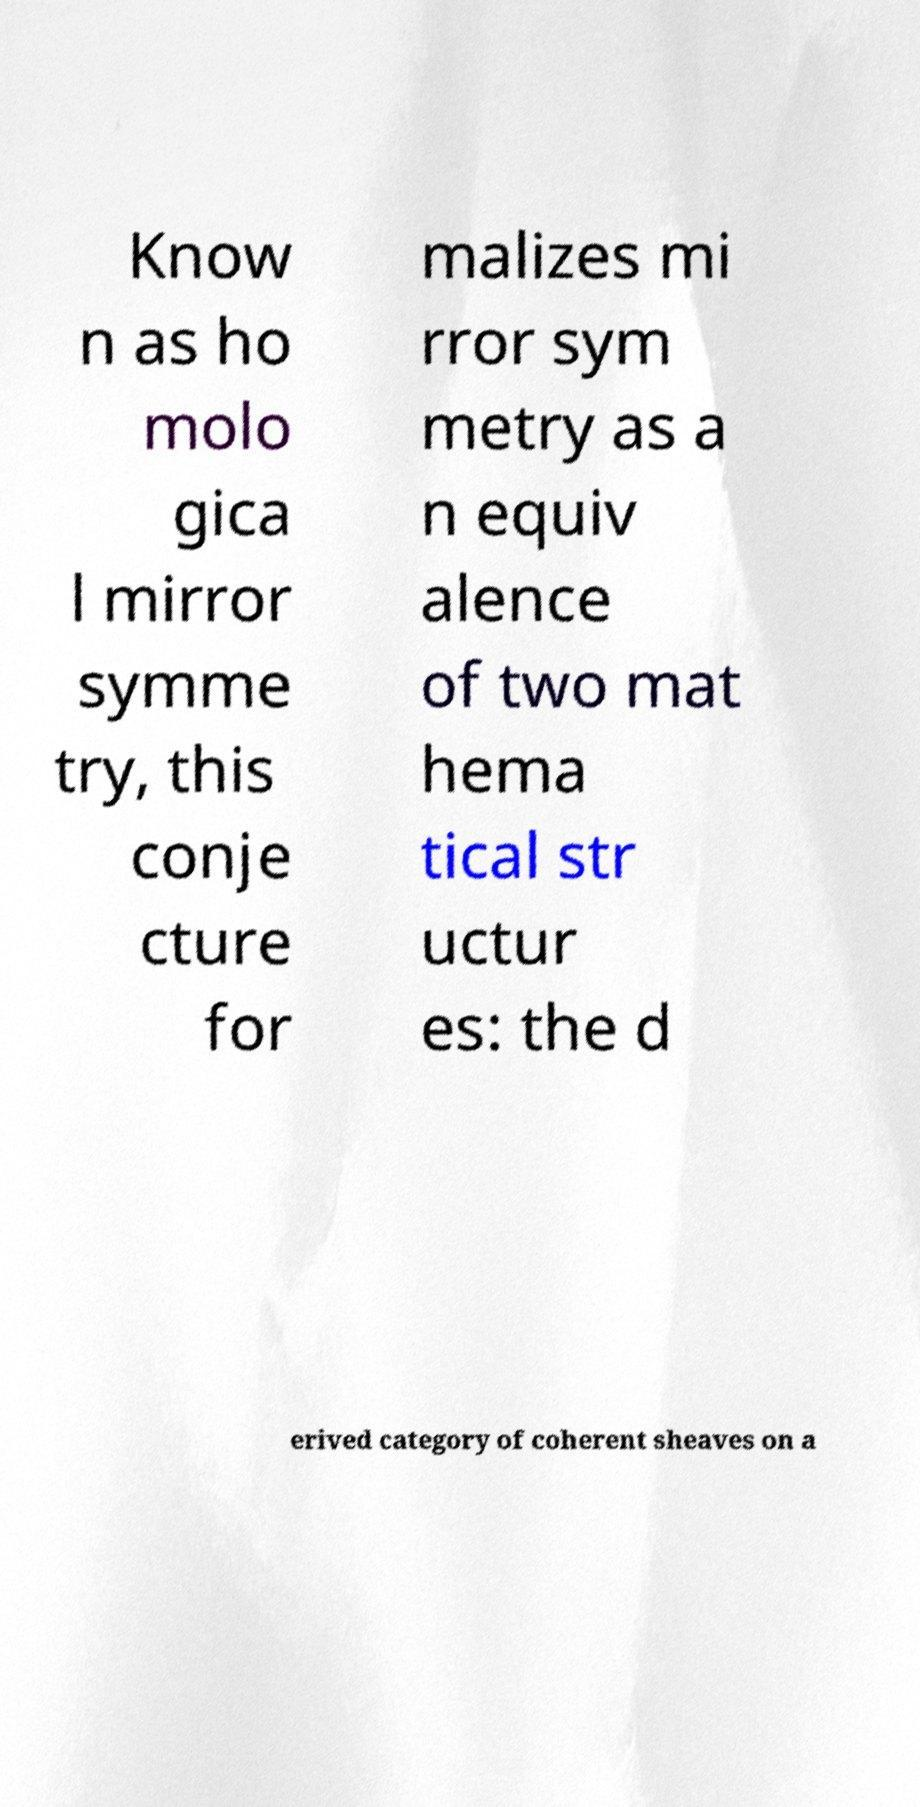What messages or text are displayed in this image? I need them in a readable, typed format. Know n as ho molo gica l mirror symme try, this conje cture for malizes mi rror sym metry as a n equiv alence of two mat hema tical str uctur es: the d erived category of coherent sheaves on a 